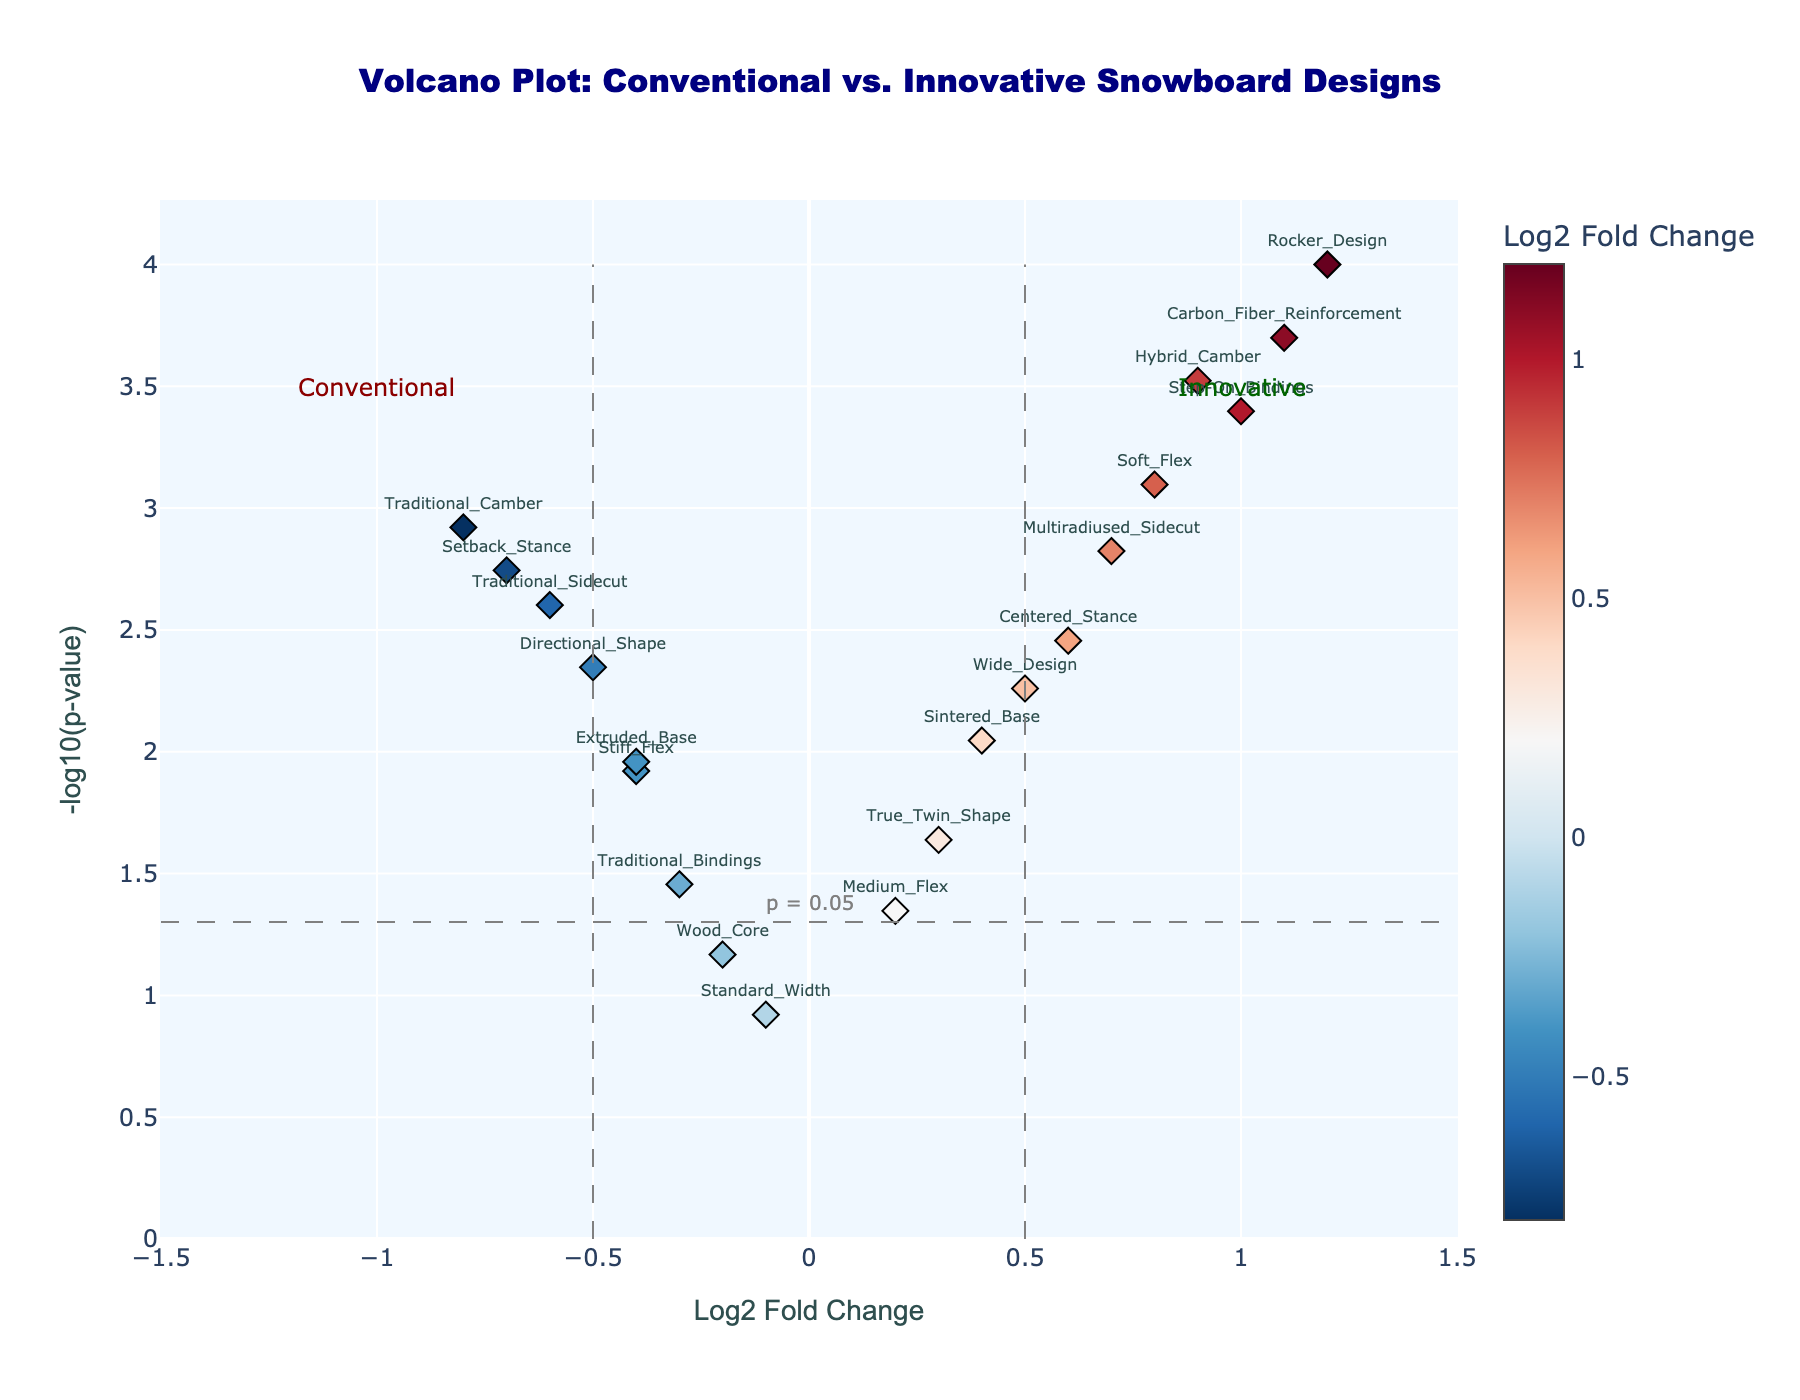What is the title of the plot? The title is typically found at the top center of the plot. In this case, it reads 'Volcano Plot: Conventional vs. Innovative Snowboard Designs'.
Answer: Volcano Plot: Conventional vs. Innovative Snowboard Designs How many features have a Log2 Fold Change (LFC) greater than 0? Count the number of points to the right of the zero mark on the x-axis. These points represent features with a positive LFC.
Answer: 10 Which feature has the highest -log10(p-value)? Identify the point with the highest value on the y-axis. The hover text or annotations near the points help with the identification. This point corresponds to the 'Rocker_Design' feature.
Answer: Rocker_Design What does the term 'Innovative' on the plot indicate? 'Innovative' is annotated on the right side of the plot, indicating that features with a positive Log2 Fold Change (>0) are considered innovative.
Answer: Innovative features have positive Log2 Fold Change What does the significance threshold line at -log10(p-value) = -log10(0.05) indicate? This is a reference line that helps to visually distinguish statistically significant features from those which are not. Features above this line are considered statistically significant.
Answer: p = 0.05 threshold for significance Which feature has the most positive Log2 Fold Change, and what is its value? Identify the point furthest to the right on the x-axis. The hover text or a nearby position label indicates that this point is the 'Rocker_Design' feature with an LFC of 1.2.
Answer: Rocker_Design, 1.2 How many features are statistically significant (p-value < 0.05)? Count the number of points above the horizontal significance threshold line at -log10(p-value) = -log10(0.05).
Answer: 16 Among 'Centered_Stance' and 'Setback_Stance', which feature has a higher -log10(p-value)? Identify the positions of these features on the y-axis and compare their values. 'Centered_Stance' has a higher -log10(p-value) compared to 'Setback_Stance'.
Answer: Centered_Stance Which features are considered statistically significant and have a negative Log2 Fold Change? These features are those that lie to the left of zero on the x-axis and above the horizontal significance threshold line. They include 'Traditional_Camber', 'Directional_Shape', 'Setback_Stance', 'Stiff_Flex', 'Traditional_Sidecut', 'Extruded_Base'.
Answer: Traditional_Camber, Directional_Shape, Setback_Stance, Stiff_Flex, Traditional_Sidecut, Extruded_Base What is the range of Log2 Fold Change values in the plot? Identify the minimum and maximum values of Log2 Fold Change from the x-axis. In this plot, the smallest value is -0.8 for 'Traditional_Camber' and the largest is 1.2 for 'Rocker_Design'.
Answer: -0.8 to 1.2 